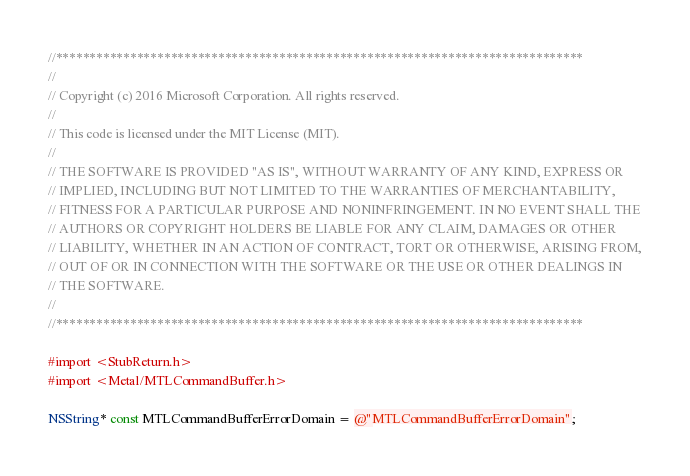Convert code to text. <code><loc_0><loc_0><loc_500><loc_500><_ObjectiveC_>//******************************************************************************
//
// Copyright (c) 2016 Microsoft Corporation. All rights reserved.
//
// This code is licensed under the MIT License (MIT).
//
// THE SOFTWARE IS PROVIDED "AS IS", WITHOUT WARRANTY OF ANY KIND, EXPRESS OR
// IMPLIED, INCLUDING BUT NOT LIMITED TO THE WARRANTIES OF MERCHANTABILITY,
// FITNESS FOR A PARTICULAR PURPOSE AND NONINFRINGEMENT. IN NO EVENT SHALL THE
// AUTHORS OR COPYRIGHT HOLDERS BE LIABLE FOR ANY CLAIM, DAMAGES OR OTHER
// LIABILITY, WHETHER IN AN ACTION OF CONTRACT, TORT OR OTHERWISE, ARISING FROM,
// OUT OF OR IN CONNECTION WITH THE SOFTWARE OR THE USE OR OTHER DEALINGS IN
// THE SOFTWARE.
//
//******************************************************************************

#import <StubReturn.h>
#import <Metal/MTLCommandBuffer.h>

NSString* const MTLCommandBufferErrorDomain = @"MTLCommandBufferErrorDomain";
</code> 